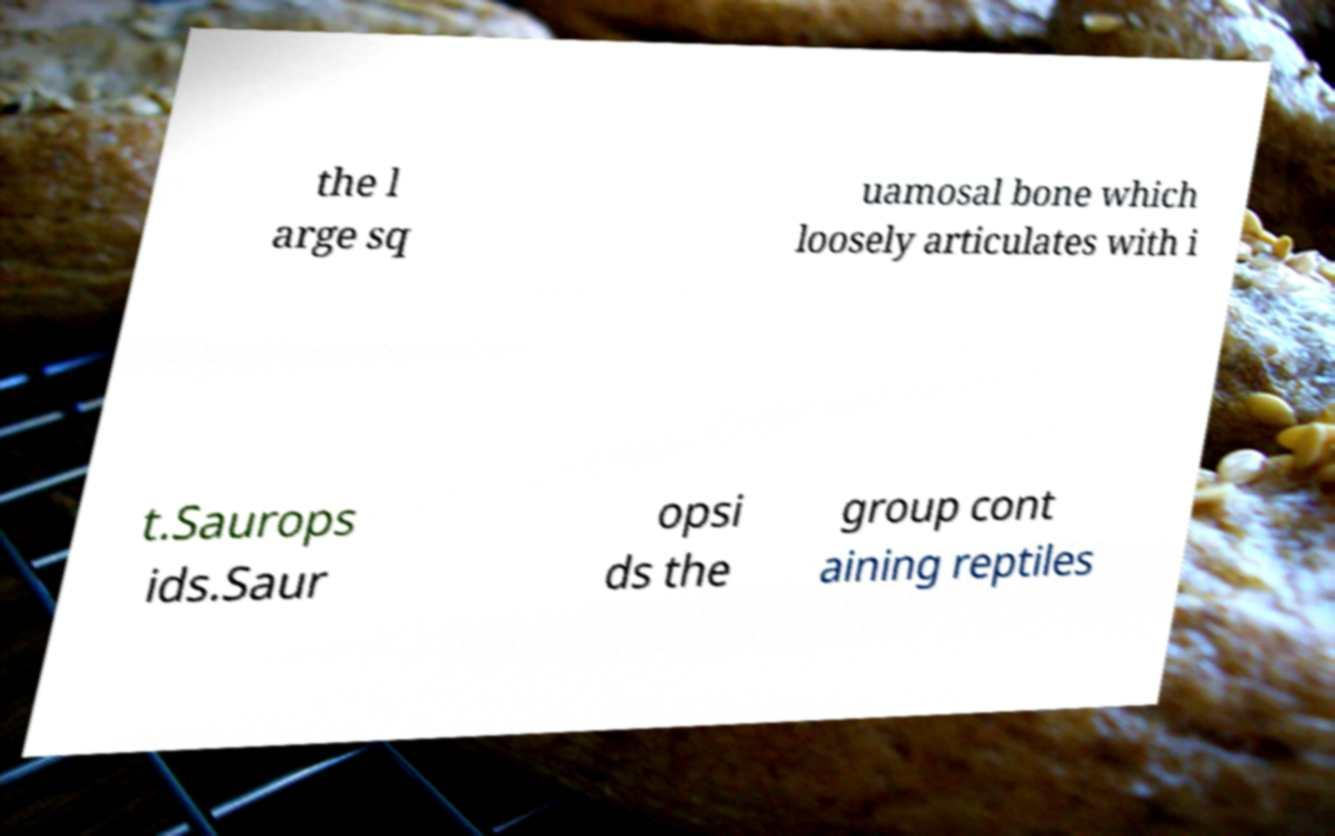For documentation purposes, I need the text within this image transcribed. Could you provide that? the l arge sq uamosal bone which loosely articulates with i t.Saurops ids.Saur opsi ds the group cont aining reptiles 